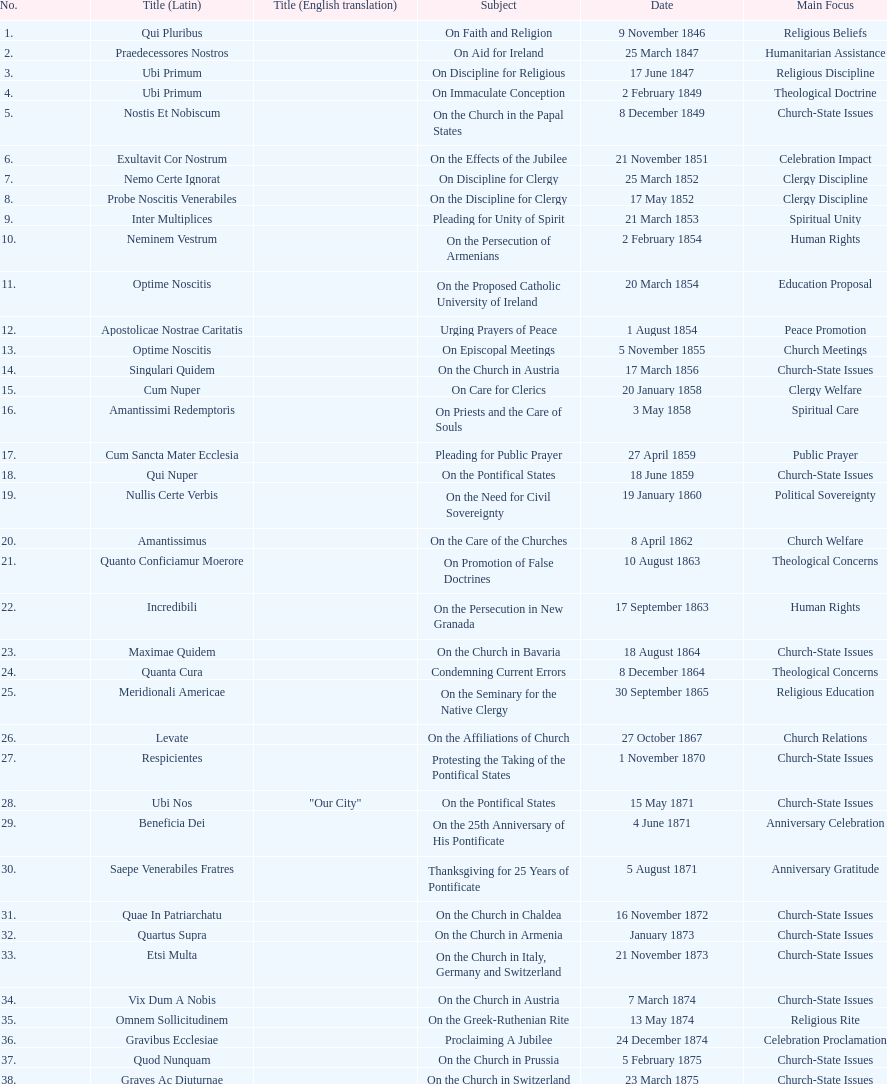In the first 10 years of his reign, how many encyclicals did pope pius ix issue? 14. 